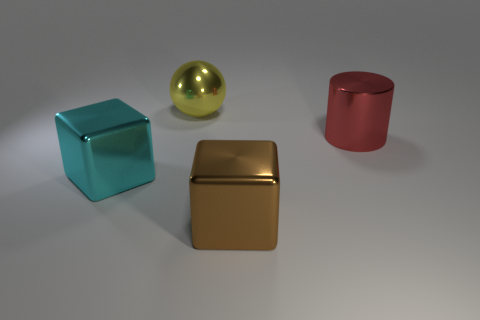Can you describe the shapes and the colors of the objects in the image? Certainly! In the image, there are four objects with distinct shapes and colors. From left to right: a turquoise cube, a reflective gold sphere, a shiny golden cube, and a matte red cylinder. Each object has its own unique texture and sheen, which adds variety to their appearance. 